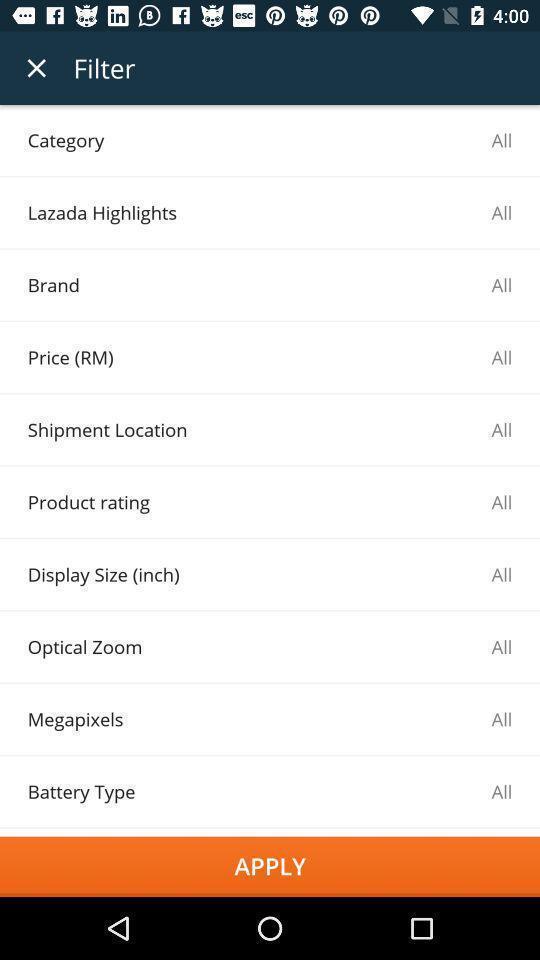Tell me about the visual elements in this screen capture. Screen shows number of filters in a shopping app. 